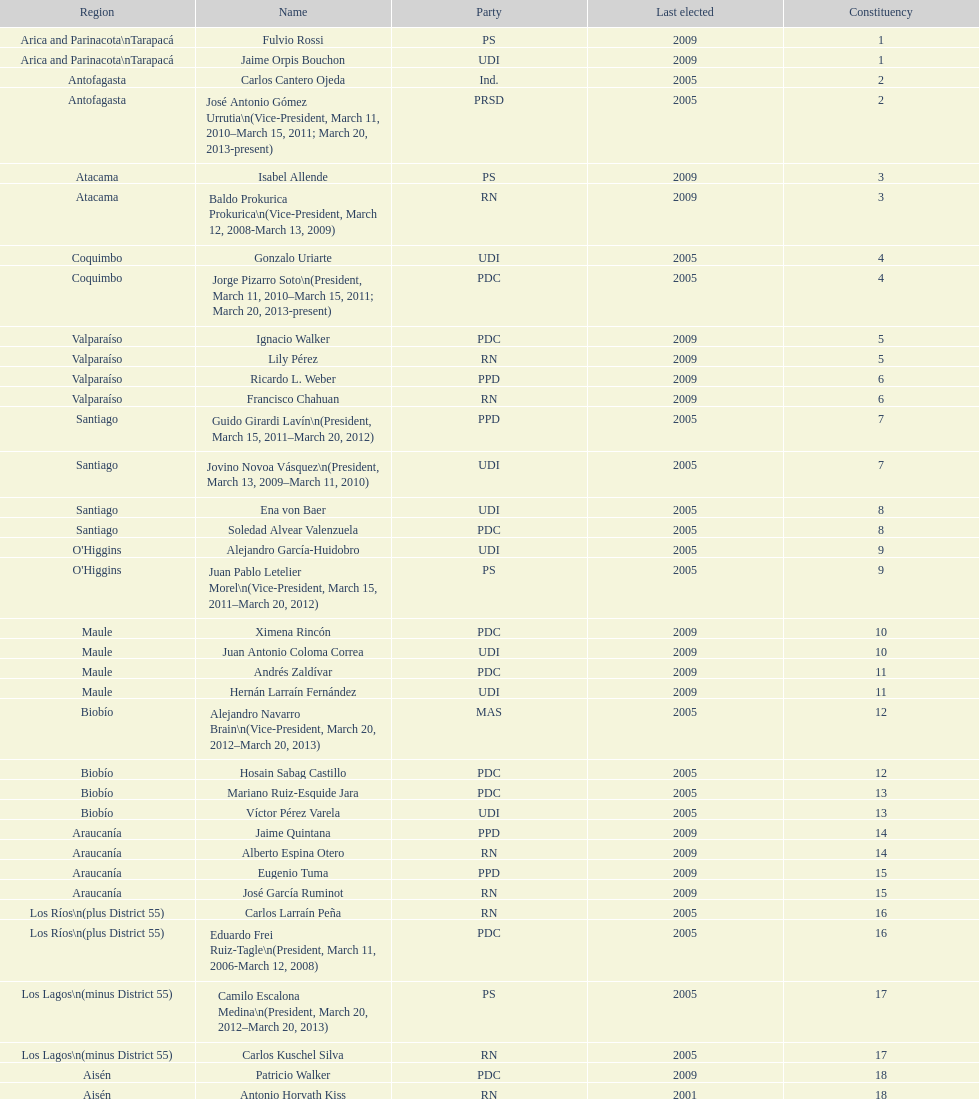What is the last region listed on the table? Magallanes. 